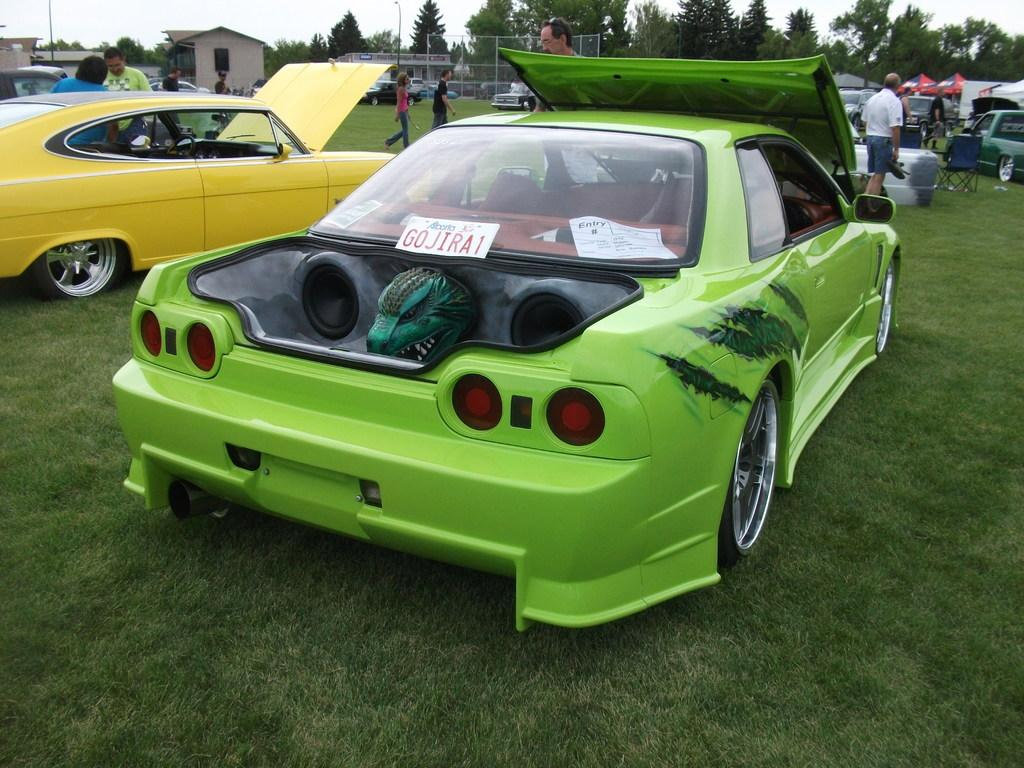<image>
Share a concise interpretation of the image provided. A bright neon green car has a plat with Go Jira1 in the back window. 